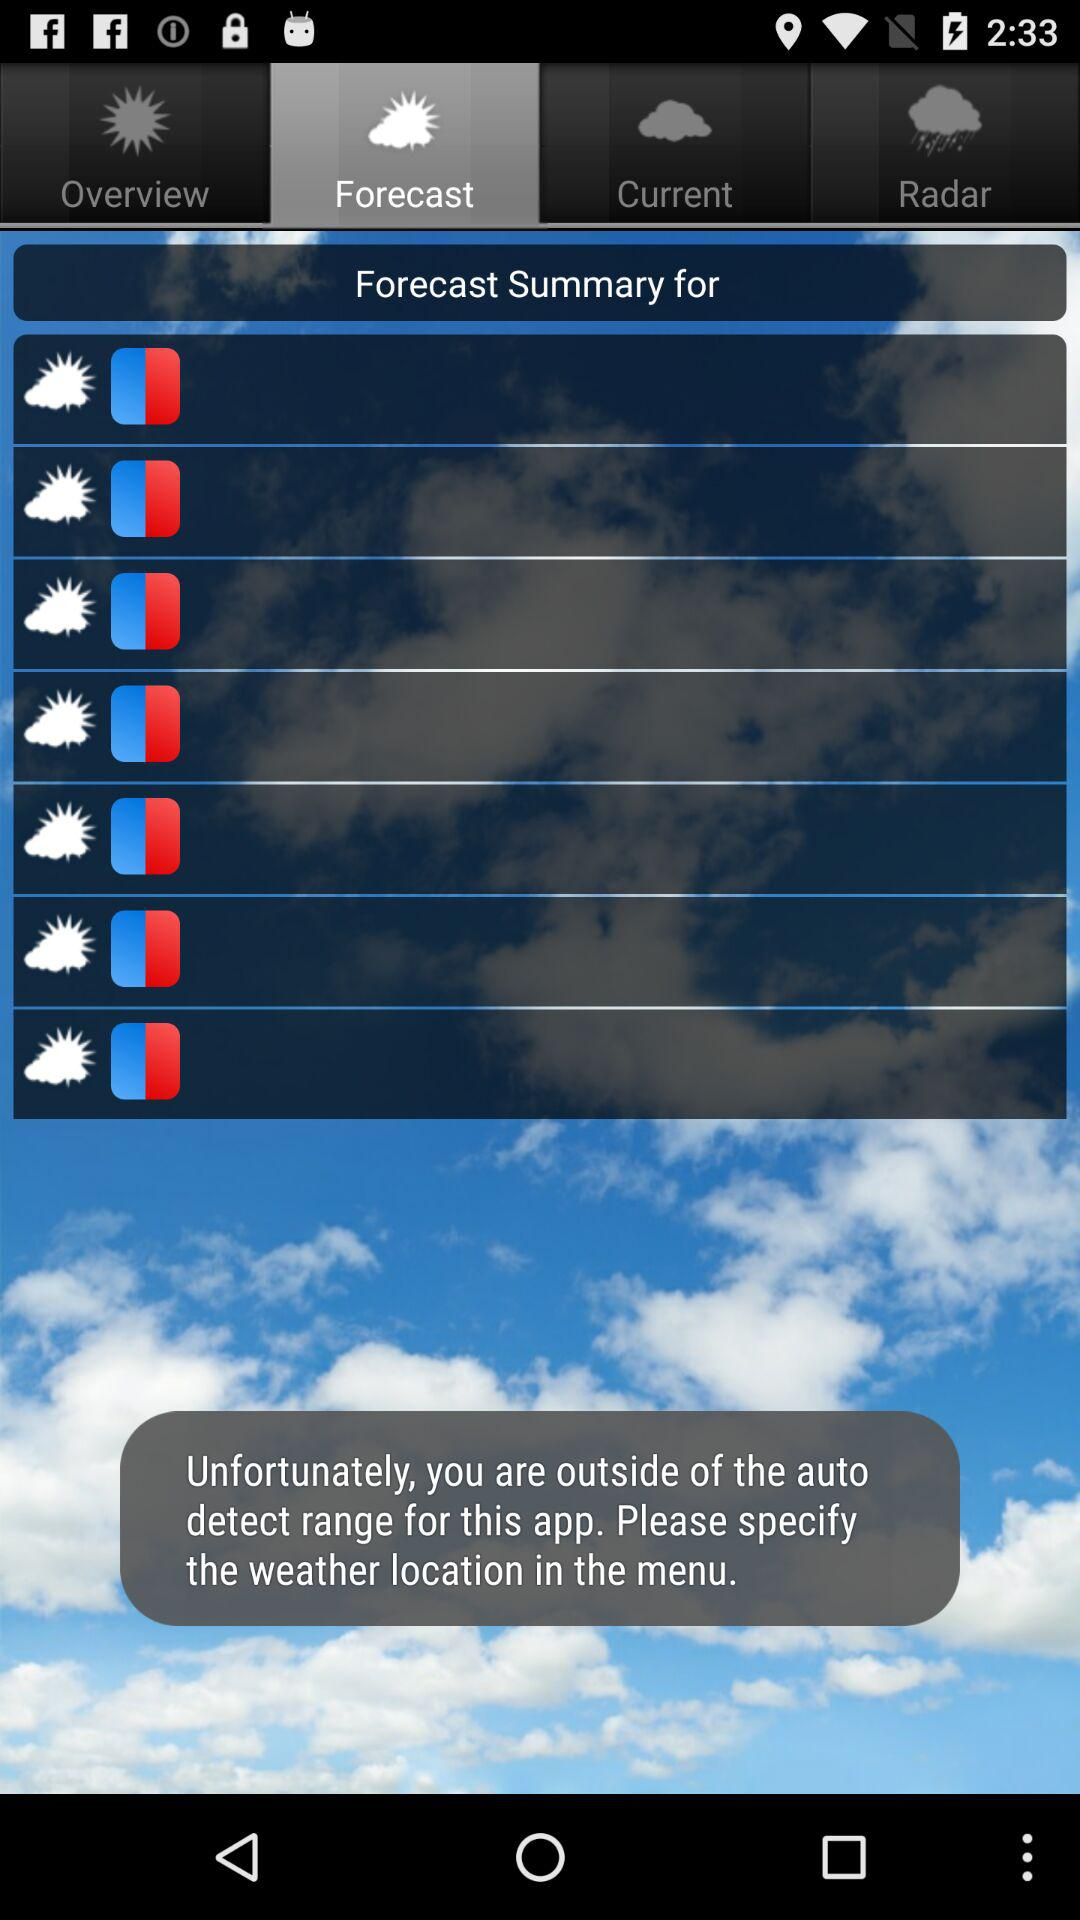Which tab is selected? The selected tab is "Forecast". 